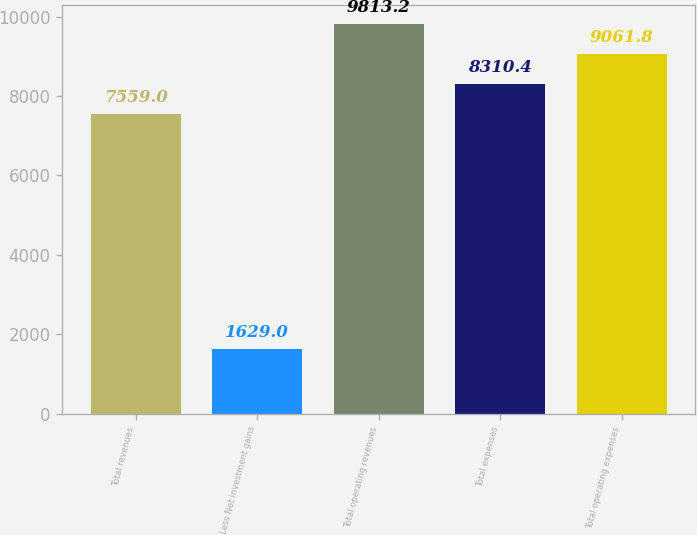Convert chart. <chart><loc_0><loc_0><loc_500><loc_500><bar_chart><fcel>Total revenues<fcel>Less Net investment gains<fcel>Total operating revenues<fcel>Total expenses<fcel>Total operating expenses<nl><fcel>7559<fcel>1629<fcel>9813.2<fcel>8310.4<fcel>9061.8<nl></chart> 